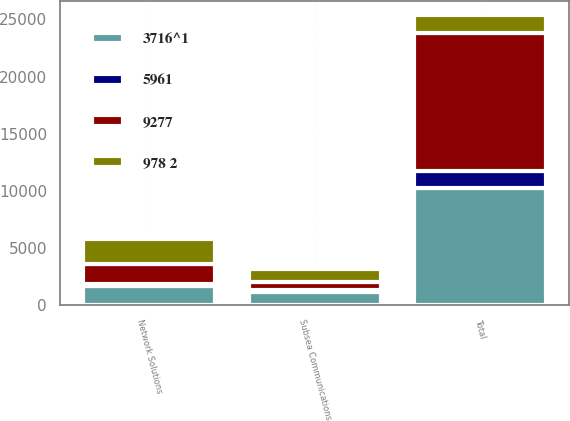Convert chart. <chart><loc_0><loc_0><loc_500><loc_500><stacked_bar_chart><ecel><fcel>Network Solutions<fcel>Subsea Communications<fcel>Total<nl><fcel>9277<fcel>1727<fcel>724<fcel>12070<nl><fcel>3716^1<fcel>1719<fcel>1161<fcel>10256<nl><fcel>978 2<fcel>2162<fcel>1165<fcel>1516<nl><fcel>5961<fcel>177<fcel>135<fcel>1516<nl></chart> 